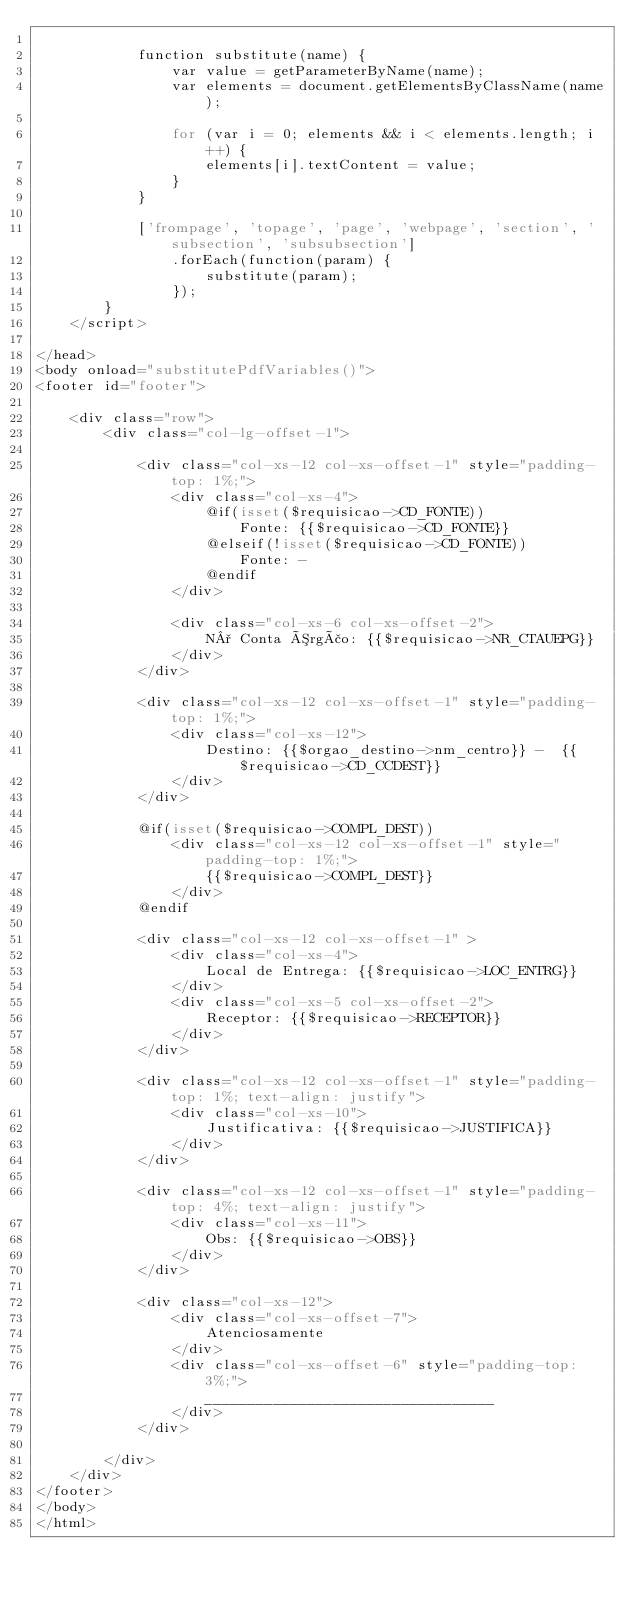Convert code to text. <code><loc_0><loc_0><loc_500><loc_500><_PHP_>
            function substitute(name) {
                var value = getParameterByName(name);
                var elements = document.getElementsByClassName(name);

                for (var i = 0; elements && i < elements.length; i++) {
                    elements[i].textContent = value;
                }
            }

            ['frompage', 'topage', 'page', 'webpage', 'section', 'subsection', 'subsubsection']
                .forEach(function(param) {
                    substitute(param);
                });
        }
    </script>

</head>
<body onload="substitutePdfVariables()">
<footer id="footer">

    <div class="row">
        <div class="col-lg-offset-1">

            <div class="col-xs-12 col-xs-offset-1" style="padding-top: 1%;">
                <div class="col-xs-4">
                    @if(isset($requisicao->CD_FONTE))
                        Fonte: {{$requisicao->CD_FONTE}}
                    @elseif(!isset($requisicao->CD_FONTE))
                        Fonte: -
                    @endif
                </div>

                <div class="col-xs-6 col-xs-offset-2">
                    N° Conta Órgão: {{$requisicao->NR_CTAUEPG}}
                </div>
            </div>

            <div class="col-xs-12 col-xs-offset-1" style="padding-top: 1%;">
                <div class="col-xs-12">
                    Destino: {{$orgao_destino->nm_centro}} -  {{$requisicao->CD_CCDEST}}
                </div>
            </div>

            @if(isset($requisicao->COMPL_DEST))
                <div class="col-xs-12 col-xs-offset-1" style="padding-top: 1%;">
                    {{$requisicao->COMPL_DEST}}
                </div>
            @endif

            <div class="col-xs-12 col-xs-offset-1" >
                <div class="col-xs-4">
                    Local de Entrega: {{$requisicao->LOC_ENTRG}}
                </div>
                <div class="col-xs-5 col-xs-offset-2">
                    Receptor: {{$requisicao->RECEPTOR}}
                </div>
            </div>

            <div class="col-xs-12 col-xs-offset-1" style="padding-top: 1%; text-align: justify">
                <div class="col-xs-10">
                    Justificativa: {{$requisicao->JUSTIFICA}}
                </div>
            </div>

            <div class="col-xs-12 col-xs-offset-1" style="padding-top: 4%; text-align: justify">
                <div class="col-xs-11">
                    Obs: {{$requisicao->OBS}}
                </div>
            </div>

            <div class="col-xs-12">
                <div class="col-xs-offset-7">
                    Atenciosamente
                </div>
                <div class="col-xs-offset-6" style="padding-top: 3%;">
                    __________________________________
                </div>
            </div>

        </div>
    </div>
</footer>
</body>
</html></code> 